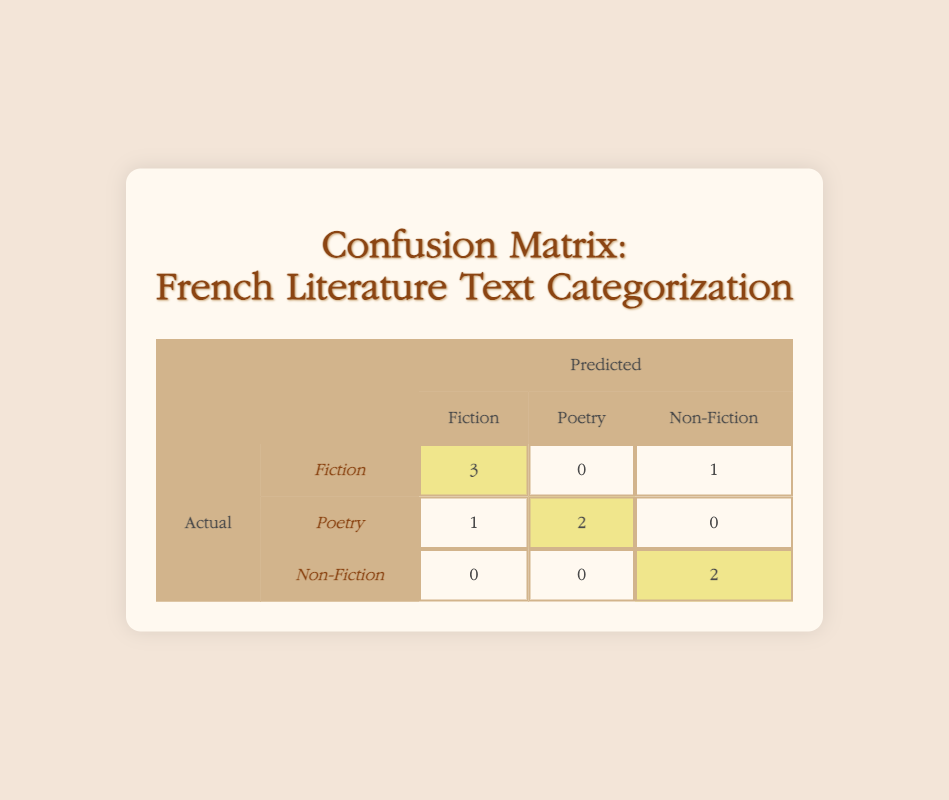What is the number of times "Fiction" was correctly predicted? In the confusion matrix, the cell for actual "Fiction" and predicted "Fiction" shows the value 3. This indicates that out of all actual "Fiction" instances, the model correctly identified them as "Fiction" three times.
Answer: 3 How many instances of "Poetry" were predicted as "Non-Fiction"? In the confusion matrix, the row for actual "Poetry" and the column for predicted "Non-Fiction" indicates the value 0. This means that none of the actual "Poetry" instances were incorrectly classified as "Non-Fiction."
Answer: 0 What is the total number of "Non-Fiction" instances in the actual data? Look at the actual values given: "Non-Fiction" appears 2 times (in positions 3 and 7). Therefore, the total count for "Non-Fiction" in the actual category is 2.
Answer: 2 What is the total number of misclassifications for "Fiction"? To find the misclassifications, we look at the row for actual "Fiction." The number of incorrectly classified instances is the sum of "Fiction" predicted as "Poetry" (0) and "Non-Fiction" (1), which adds up to 1.
Answer: 1 Are there more instances of "Poetry" predicted as "Fiction" than "Poetry" predicted as "Non-Fiction"? In the confusion matrix, the row for actual "Poetry" shows 1 instance predicted as "Fiction" and 0 instances predicted as "Non-Fiction." Therefore, yes, there is 1 instance predicted as "Fiction" and 0 as "Non-Fiction," confirming the statement is true.
Answer: Yes How many instances of "Poetry" were correctly predicted? The matrix shows that for actual "Poetry," the model predicted "Poetry" correctly with the value 2. This means that there were two instances where "Poetry" was accurately categorized as "Poetry."
Answer: 2 What is the total number of instances predicted as "Fiction"? To find this, sum the values in the "Fiction" column: 3 (actual "Fiction") + 1 (actual "Poetry") + 0 (actual "Non-Fiction") which equals 4. Therefore, the model predicted 4 instances as "Fiction."
Answer: 4 What is the specificity of the model for "Poetry"? Specificity is defined as the true negatives divided by the sum of true negatives and false positives. In this case, true negatives for "Poetry" are the actual "Fiction" instances predicted as "Fiction" (3) and actual "Non-Fiction" that are predicted correctly (2). The total true negatives are 3 + 2 = 5. The false positives for "Poetry" are from actual "Fiction" and "Non-Fiction" predicted as "Poetry," which are 1 for "Fiction" and 0 for "Non-Fiction." Thus, specificity = 5 (true negatives) / (5 + 1) = 5/6.
Answer: 5/6 What is the average number of correct predictions across all categories? To calculate the average, first determine the correct categories: 3 for "Fiction," 2 for "Poetry," and 2 for "Non-Fiction," totaling 7 correct predictions. Divide this by the number of categories (3): 7/3 = 2.33.
Answer: 2.33 